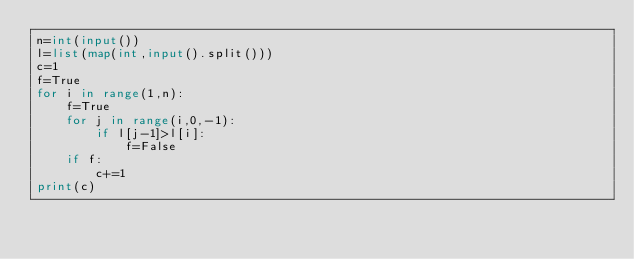Convert code to text. <code><loc_0><loc_0><loc_500><loc_500><_Python_>n=int(input())
l=list(map(int,input().split()))
c=1
f=True
for i in range(1,n):
    f=True
    for j in range(i,0,-1):
        if l[j-1]>l[i]:
            f=False
    if f:
        c+=1
print(c)</code> 